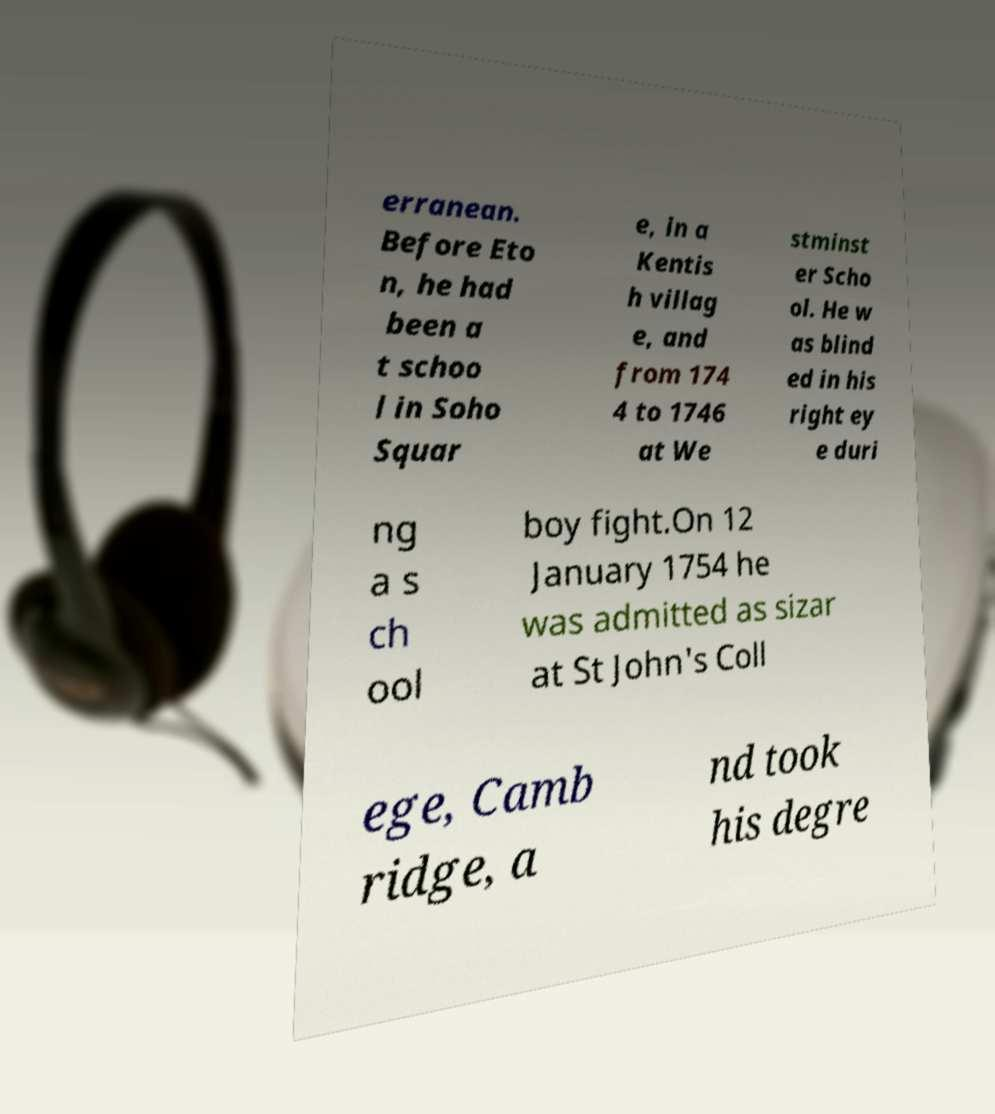Could you extract and type out the text from this image? erranean. Before Eto n, he had been a t schoo l in Soho Squar e, in a Kentis h villag e, and from 174 4 to 1746 at We stminst er Scho ol. He w as blind ed in his right ey e duri ng a s ch ool boy fight.On 12 January 1754 he was admitted as sizar at St John's Coll ege, Camb ridge, a nd took his degre 